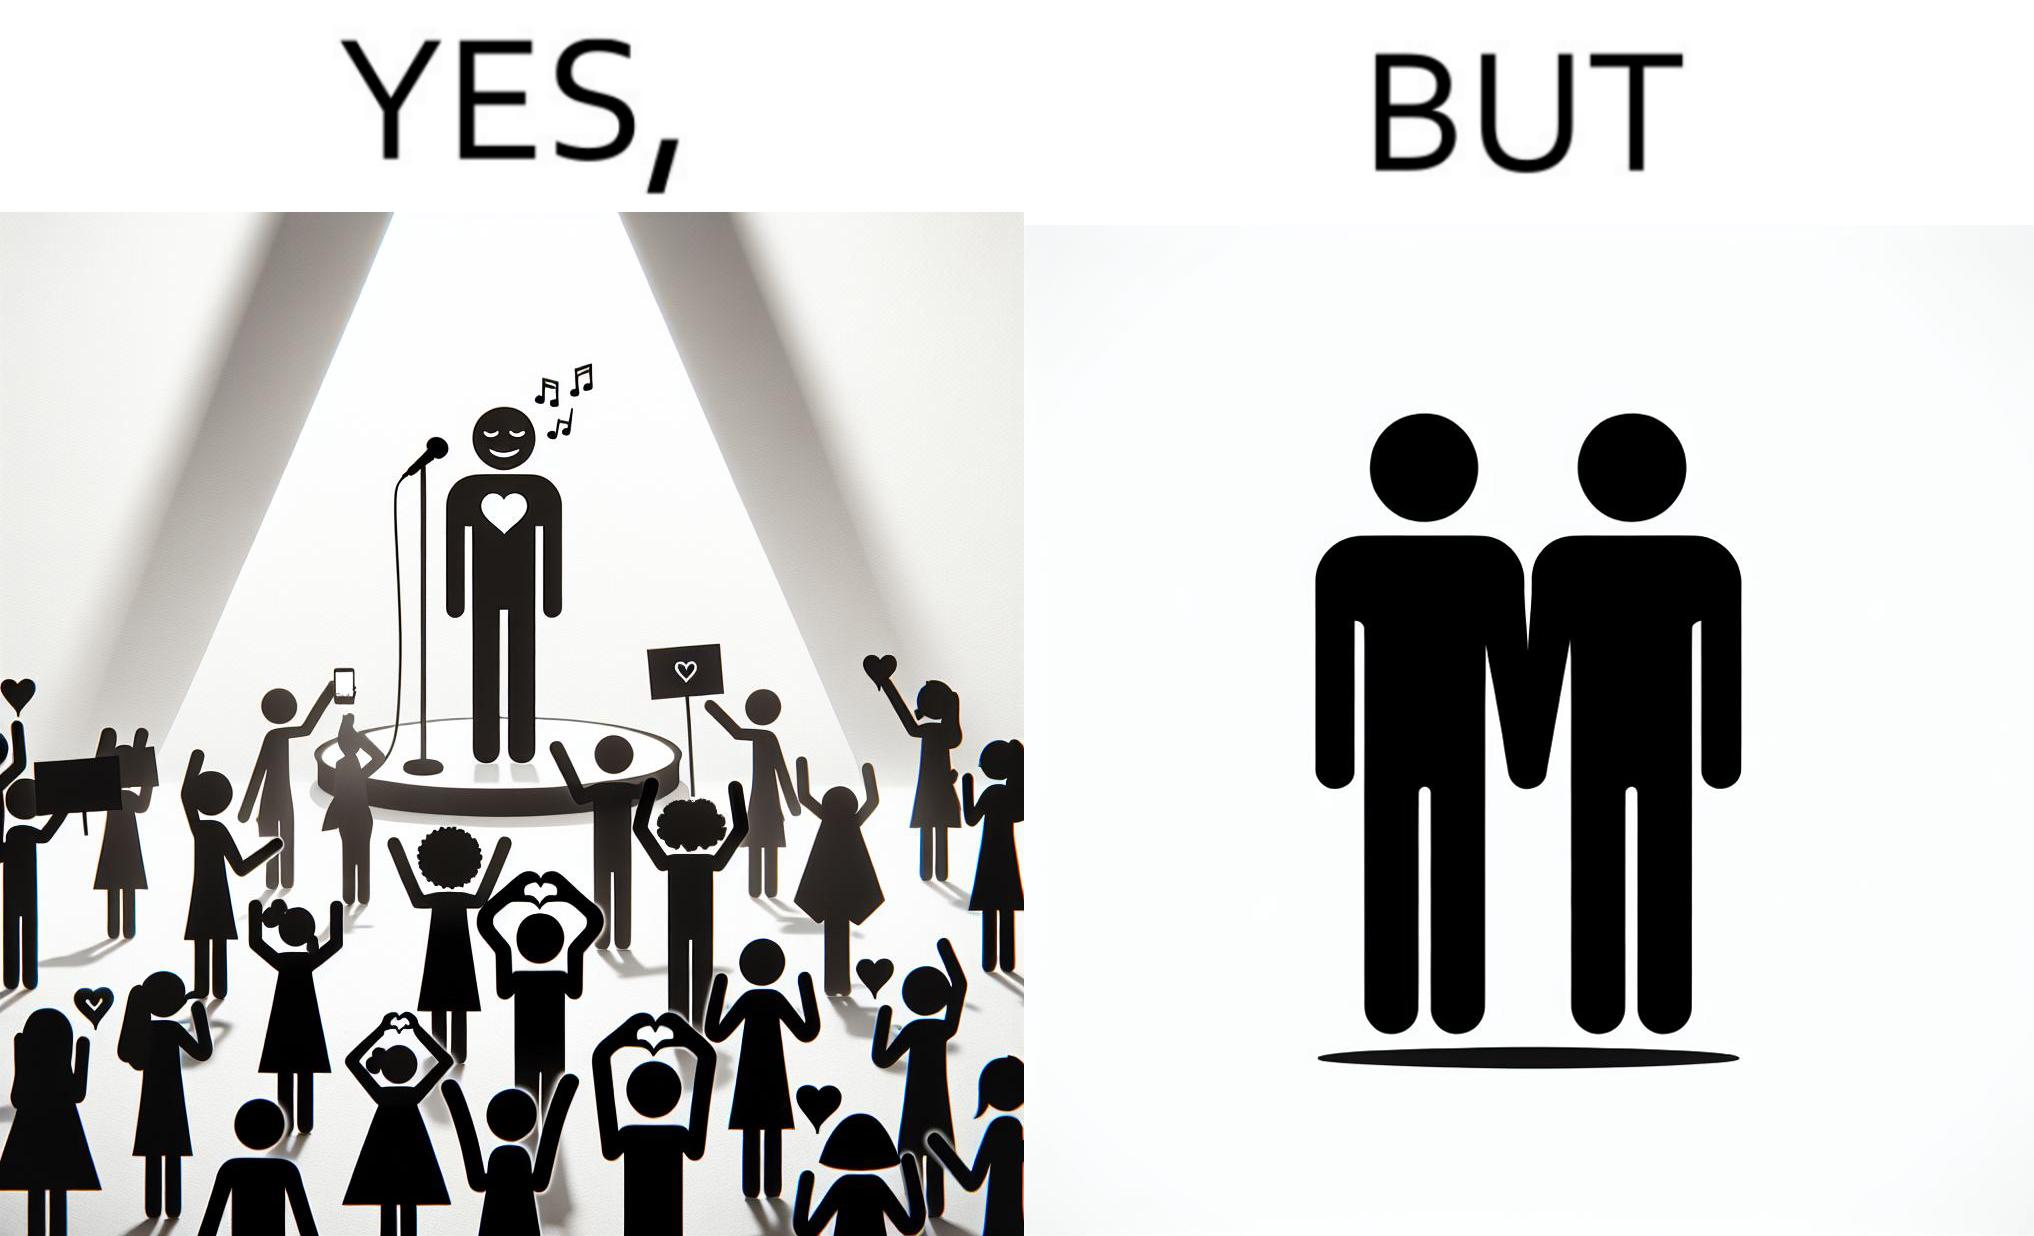Is this a satirical image? Yes, this image is satirical. 